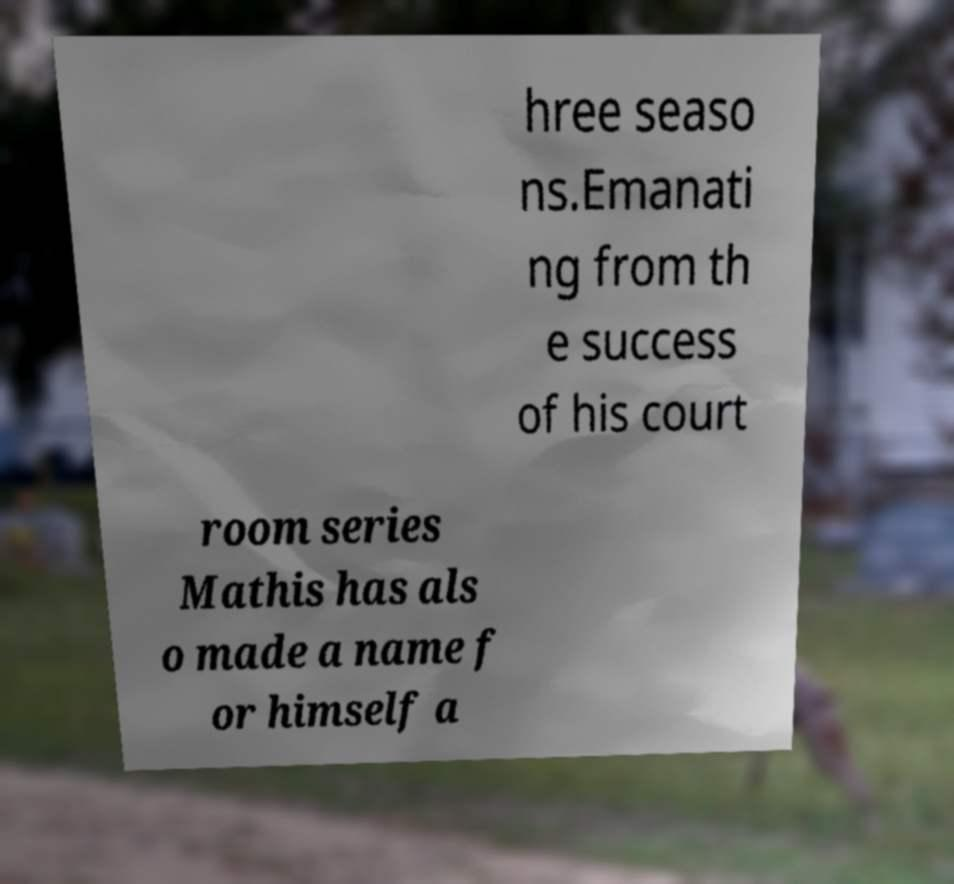For documentation purposes, I need the text within this image transcribed. Could you provide that? hree seaso ns.Emanati ng from th e success of his court room series Mathis has als o made a name f or himself a 